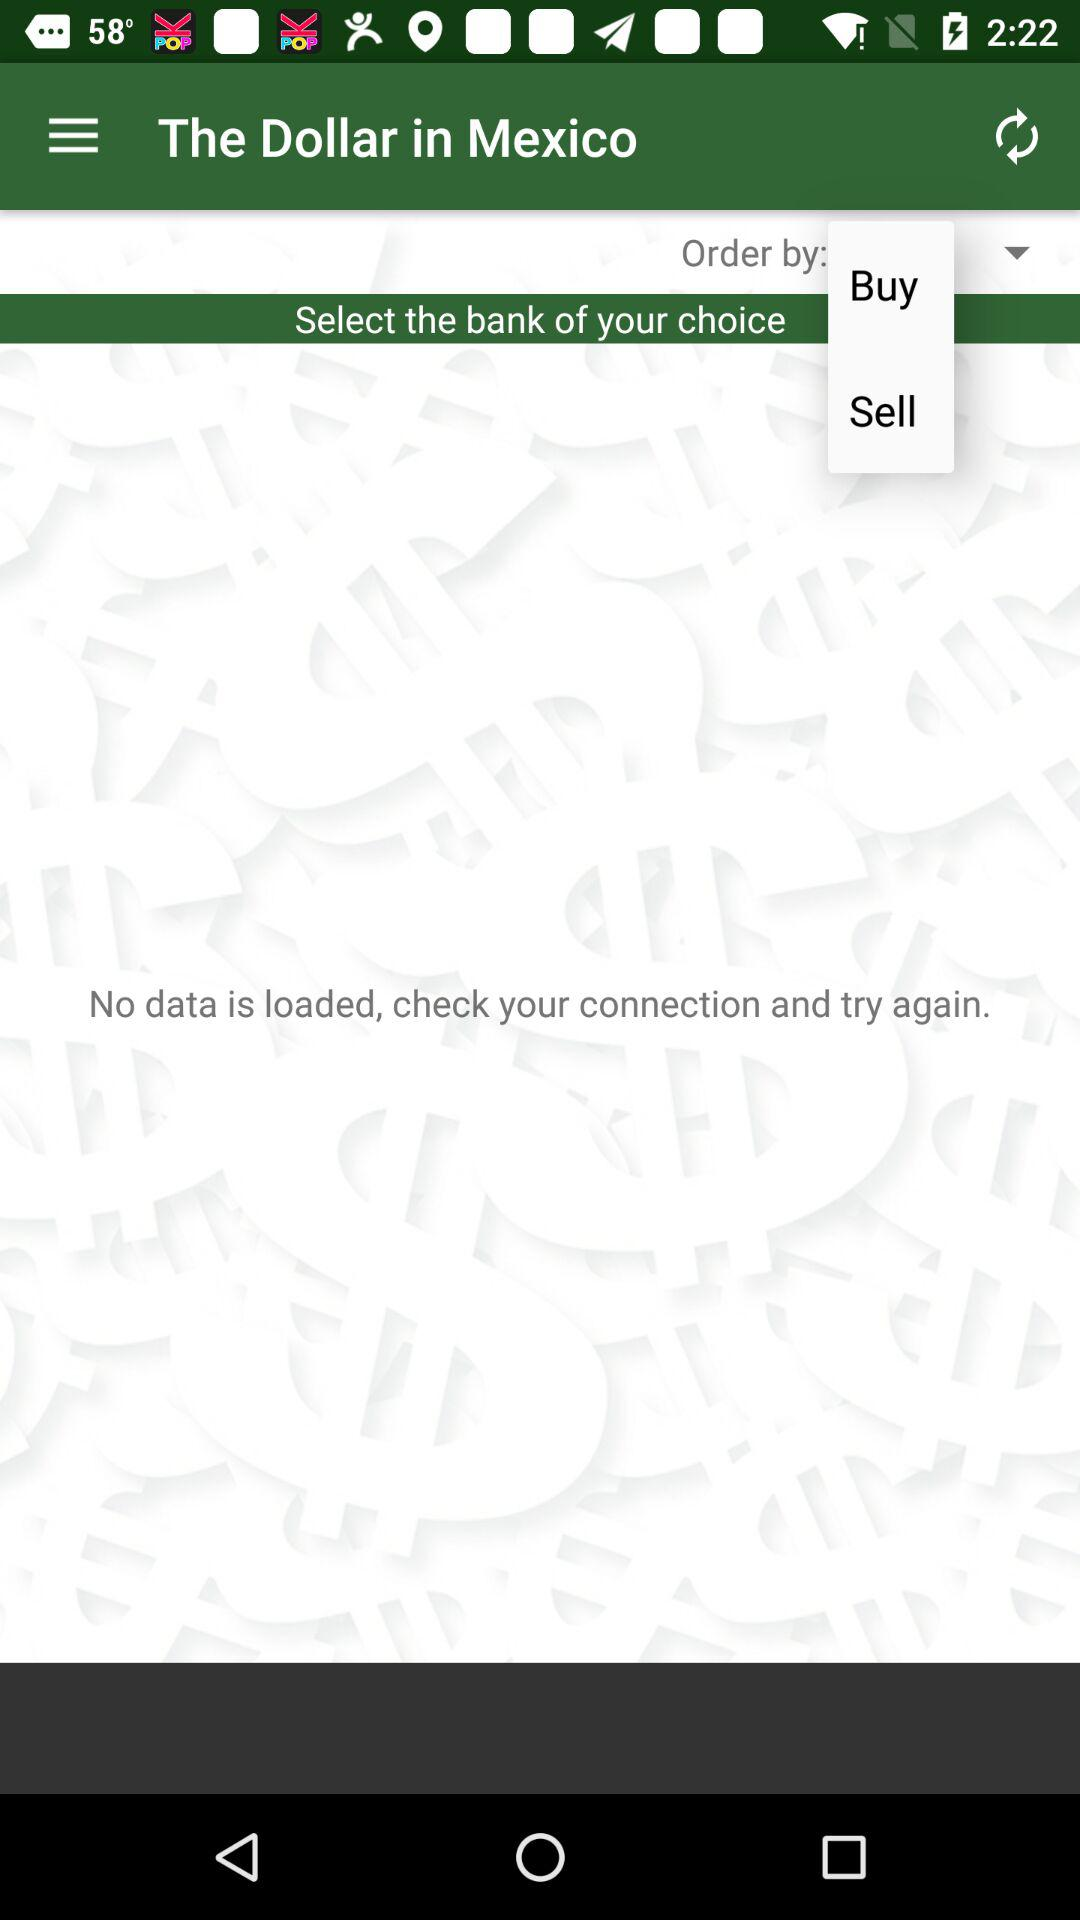What is the username?
When the provided information is insufficient, respond with <no answer>. <no answer> 